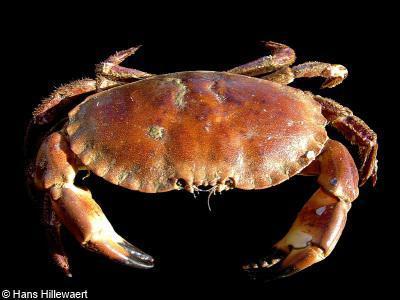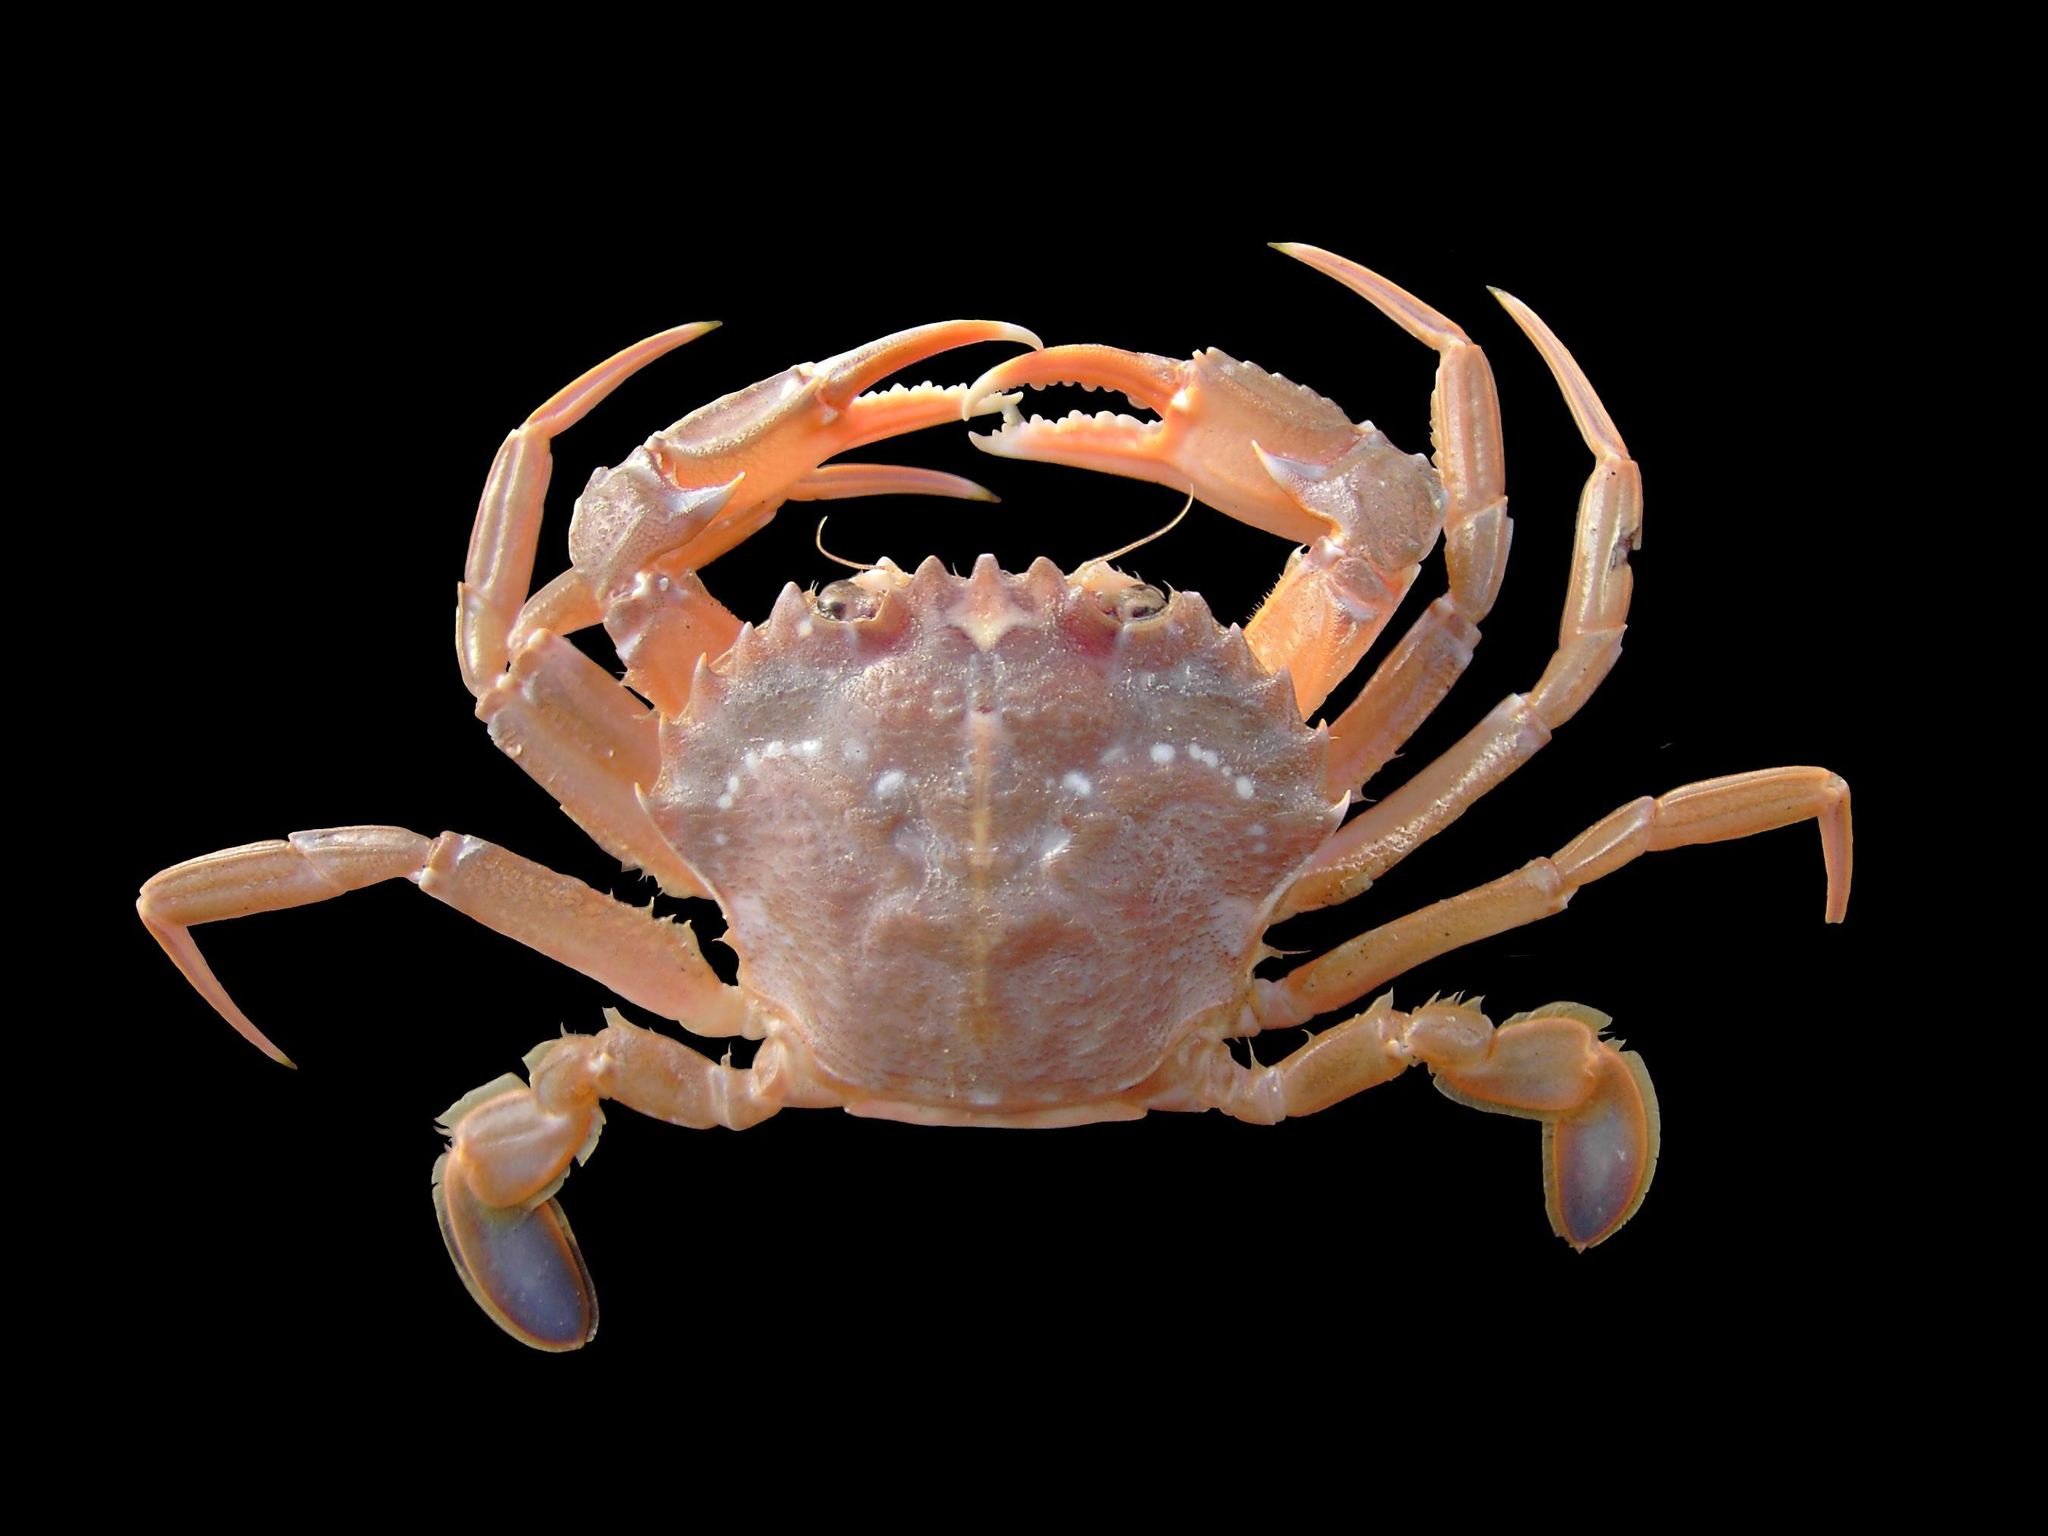The first image is the image on the left, the second image is the image on the right. For the images displayed, is the sentence "The crabs have the same orientation." factually correct? Answer yes or no. No. The first image is the image on the left, the second image is the image on the right. For the images displayed, is the sentence "Each image shows a top-view of a crab with its face and its larger front claws at the top, and its shell facing forward." factually correct? Answer yes or no. No. 